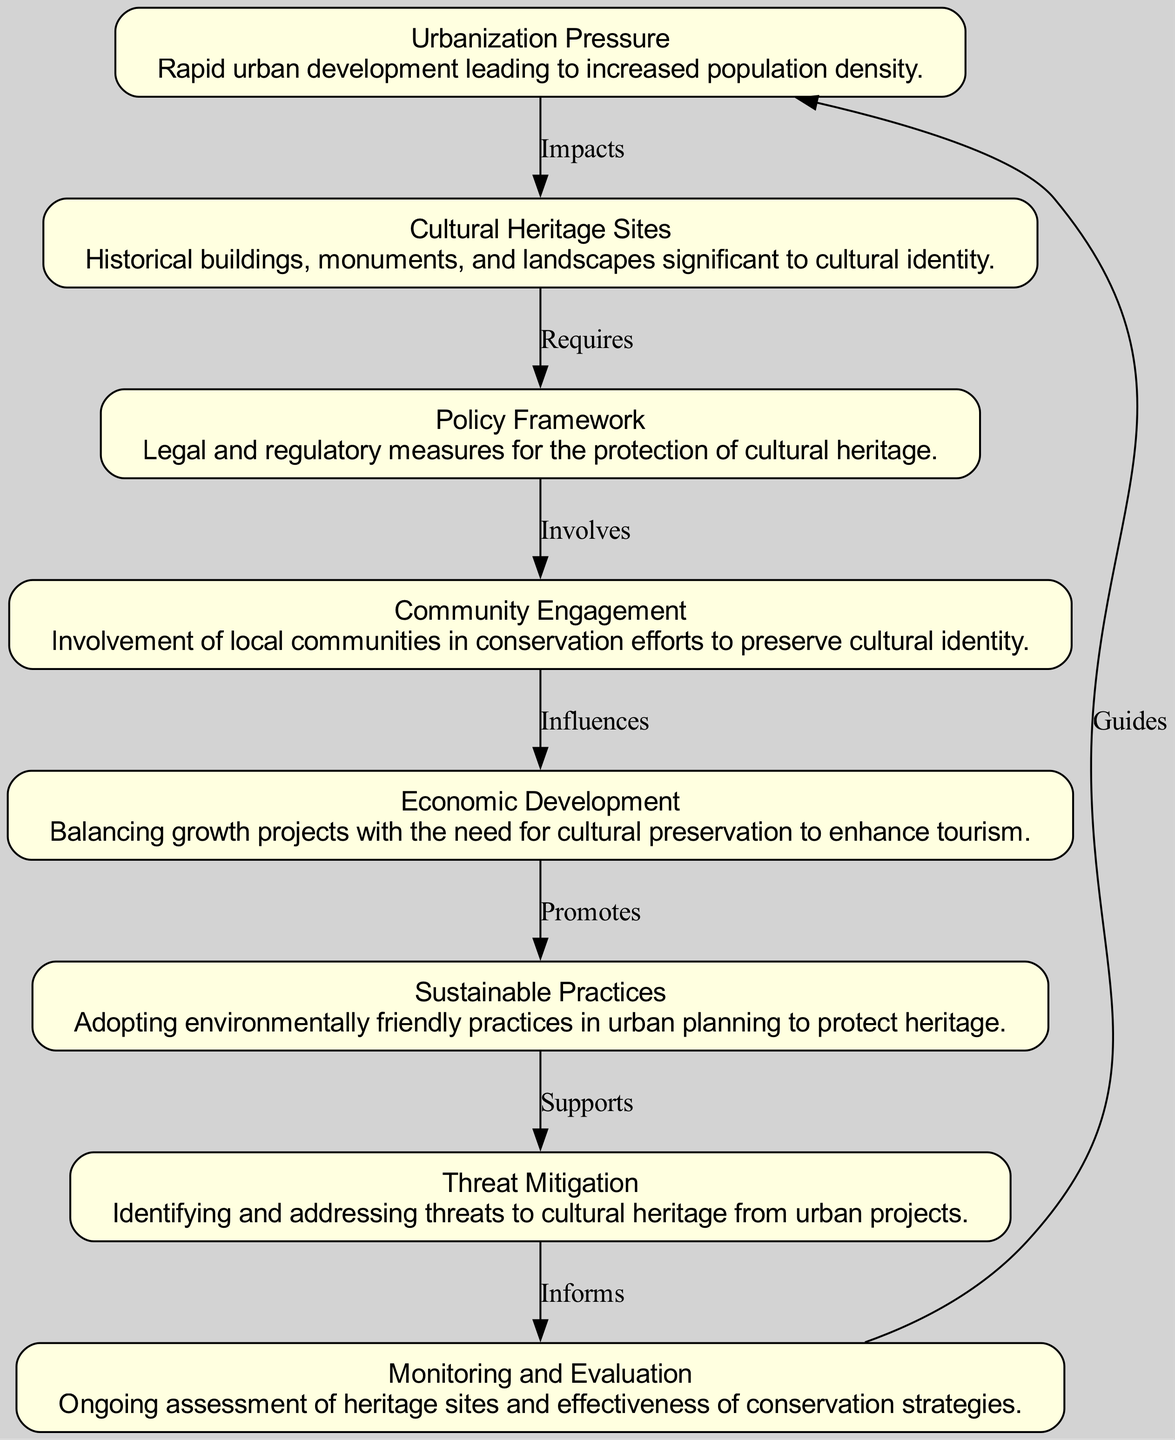What node directly influences economic development in the chart? The node that directly influences economic development is "Community Engagement." According to the diagram, there is an edge from "Community Engagement" to "Economic Development," indicating that local community involvement plays a crucial role in this aspect.
Answer: Community Engagement How many nodes are in the flow chart? By examining the diagram, we can count the distinct elements presented as nodes. There are a total of eight nodes listed in the flowchart.
Answer: 8 What does "Cultural Heritage Sites" require according to the diagram? The diagram states that "Cultural Heritage Sites" require a "Policy Framework." This is indicated by the direct edge connecting these two nodes with the label "Requires."
Answer: Policy Framework What supports monitoring and evaluation? The node that supports monitoring and evaluation is "Threat Mitigation." In the flow, "Threat Mitigation" has a direct connection to "Monitoring and Evaluation" with the label "Informs," suggesting it provides necessary information for effective assessment.
Answer: Threat Mitigation What relationship exists between sustainable practices and economic development? The relation between these two nodes is indirect. "Sustainable Practices" promotes the need for "Economic Development" through a sequence of relationships: "Economic Development" is influenced by "Community Engagement," which comes after "Sustainable Practices." Hence, while they don't connect directly, they are part of the larger flow of the diagram.
Answer: Promotes What guides urbanization pressure in the diagram? The diagram shows that "Monitoring and Evaluation" guides "Urbanization Pressure." There is a flow back to "Urbanization Pressure" from "Monitoring and Evaluation," which indicates that ongoing assessment provides guidance regarding urbanization impacts on cultural heritage.
Answer: Monitoring and Evaluation Which node involves local communities in its efforts? The node that involves local communities is "Community Engagement." It is specifically identified as the element that entails the participation of local people in conservation efforts as represented in the flow chart.
Answer: Community Engagement What is the impact of urbanization pressure on cultural heritage sites? The impact of urbanization pressure, as per the chart, is that it leads to threats against "Cultural Heritage Sites." The edge labeled "Impacts" connects these two nodes, directly indicating the influence of urbanization on heritage.
Answer: Threats Which element is balanced with the need for cultural preservation? The element balanced with the need for cultural preservation is "Economic Development." The diagram describes this relationship, emphasizing the need to harmonize growth projects with heritage conservation.
Answer: Economic Development 